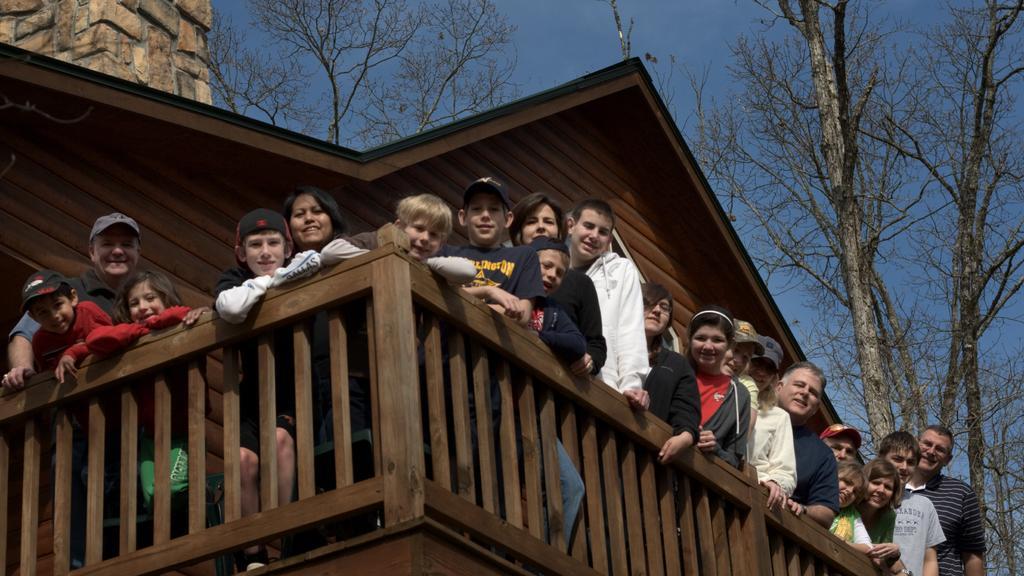Can you describe this image briefly? In this image we can see people, railing, and wooden wall. In the background there are trees, rock wall, and sky. 